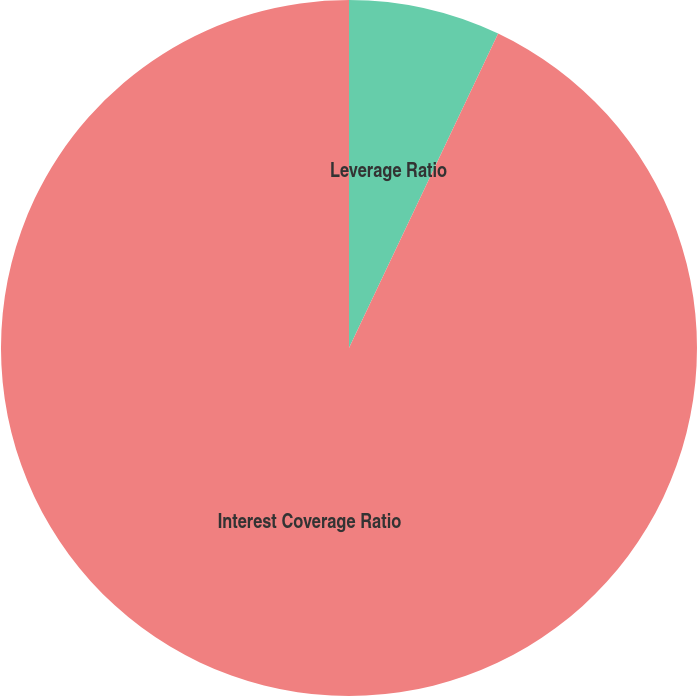Convert chart to OTSL. <chart><loc_0><loc_0><loc_500><loc_500><pie_chart><fcel>Leverage Ratio<fcel>Interest Coverage Ratio<nl><fcel>7.05%<fcel>92.95%<nl></chart> 